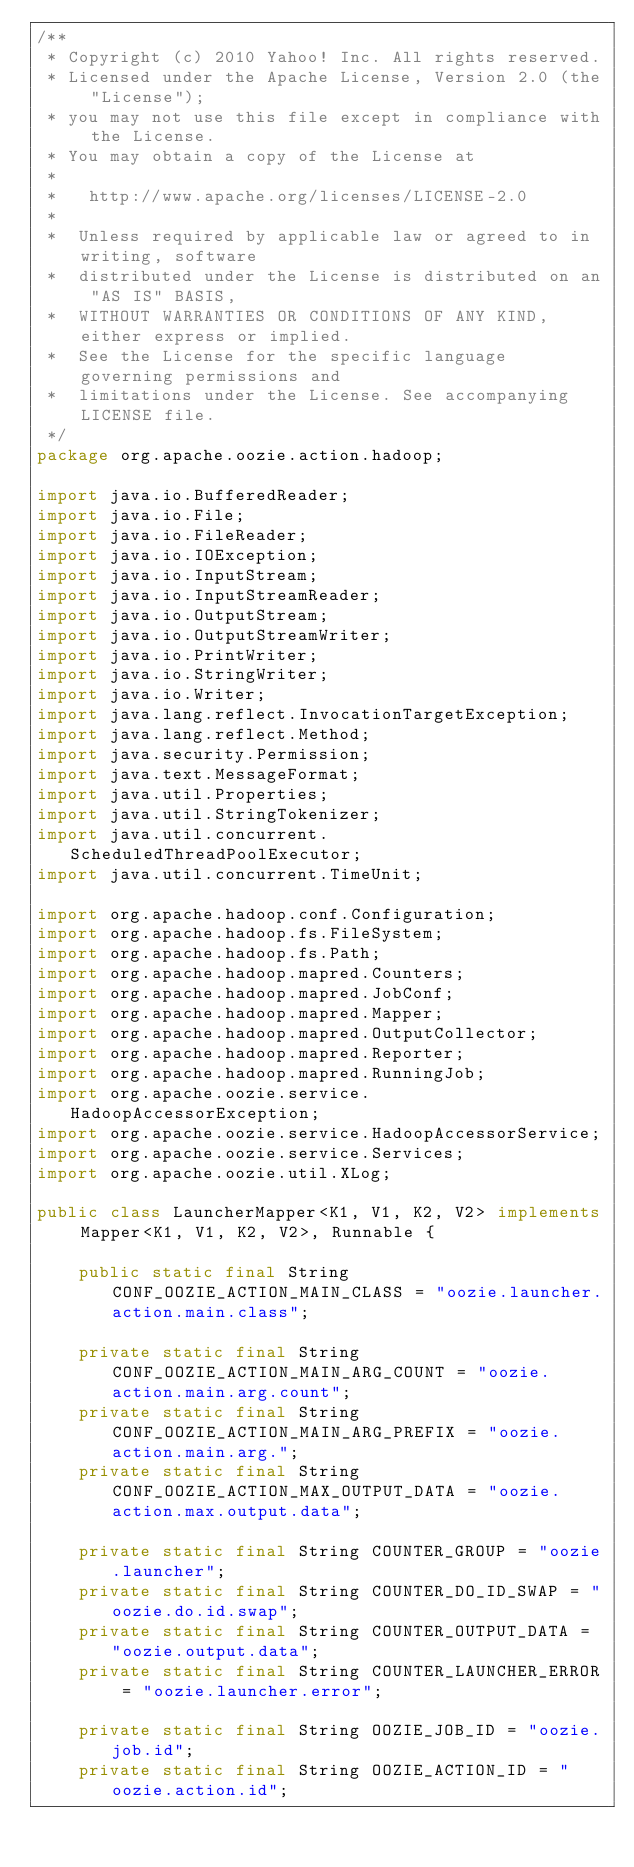Convert code to text. <code><loc_0><loc_0><loc_500><loc_500><_Java_>/**
 * Copyright (c) 2010 Yahoo! Inc. All rights reserved.
 * Licensed under the Apache License, Version 2.0 (the "License");
 * you may not use this file except in compliance with the License.
 * You may obtain a copy of the License at
 *
 *   http://www.apache.org/licenses/LICENSE-2.0
 *
 *  Unless required by applicable law or agreed to in writing, software
 *  distributed under the License is distributed on an "AS IS" BASIS,
 *  WITHOUT WARRANTIES OR CONDITIONS OF ANY KIND, either express or implied.
 *  See the License for the specific language governing permissions and
 *  limitations under the License. See accompanying LICENSE file.
 */
package org.apache.oozie.action.hadoop;

import java.io.BufferedReader;
import java.io.File;
import java.io.FileReader;
import java.io.IOException;
import java.io.InputStream;
import java.io.InputStreamReader;
import java.io.OutputStream;
import java.io.OutputStreamWriter;
import java.io.PrintWriter;
import java.io.StringWriter;
import java.io.Writer;
import java.lang.reflect.InvocationTargetException;
import java.lang.reflect.Method;
import java.security.Permission;
import java.text.MessageFormat;
import java.util.Properties;
import java.util.StringTokenizer;
import java.util.concurrent.ScheduledThreadPoolExecutor;
import java.util.concurrent.TimeUnit;

import org.apache.hadoop.conf.Configuration;
import org.apache.hadoop.fs.FileSystem;
import org.apache.hadoop.fs.Path;
import org.apache.hadoop.mapred.Counters;
import org.apache.hadoop.mapred.JobConf;
import org.apache.hadoop.mapred.Mapper;
import org.apache.hadoop.mapred.OutputCollector;
import org.apache.hadoop.mapred.Reporter;
import org.apache.hadoop.mapred.RunningJob;
import org.apache.oozie.service.HadoopAccessorException;
import org.apache.oozie.service.HadoopAccessorService;
import org.apache.oozie.service.Services;
import org.apache.oozie.util.XLog;

public class LauncherMapper<K1, V1, K2, V2> implements Mapper<K1, V1, K2, V2>, Runnable {

    public static final String CONF_OOZIE_ACTION_MAIN_CLASS = "oozie.launcher.action.main.class";

    private static final String CONF_OOZIE_ACTION_MAIN_ARG_COUNT = "oozie.action.main.arg.count";
    private static final String CONF_OOZIE_ACTION_MAIN_ARG_PREFIX = "oozie.action.main.arg.";
    private static final String CONF_OOZIE_ACTION_MAX_OUTPUT_DATA = "oozie.action.max.output.data";

    private static final String COUNTER_GROUP = "oozie.launcher";
    private static final String COUNTER_DO_ID_SWAP = "oozie.do.id.swap";
    private static final String COUNTER_OUTPUT_DATA = "oozie.output.data";
    private static final String COUNTER_LAUNCHER_ERROR = "oozie.launcher.error";

    private static final String OOZIE_JOB_ID = "oozie.job.id";
    private static final String OOZIE_ACTION_ID = "oozie.action.id";
</code> 